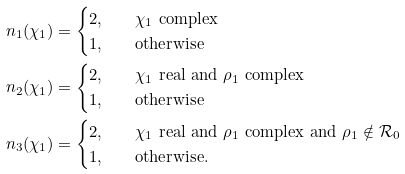Convert formula to latex. <formula><loc_0><loc_0><loc_500><loc_500>n _ { 1 } ( \chi _ { 1 } ) & = \begin{cases} 2 , \quad & \chi _ { 1 } \text { complex} \\ 1 , & \text {otherwise} \end{cases} \\ n _ { 2 } ( \chi _ { 1 } ) & = \begin{cases} 2 , \quad & \chi _ { 1 } \text { real and } \rho _ { 1 } \text { complex} \\ 1 , & \text {otherwise} \end{cases} \\ n _ { 3 } ( \chi _ { 1 } ) & = \begin{cases} 2 , \quad & \chi _ { 1 } \text { real and } \rho _ { 1 } \text { complex and } \rho _ { 1 } \notin \mathcal { R } _ { 0 } \\ 1 , & \text {otherwise.} \end{cases}</formula> 